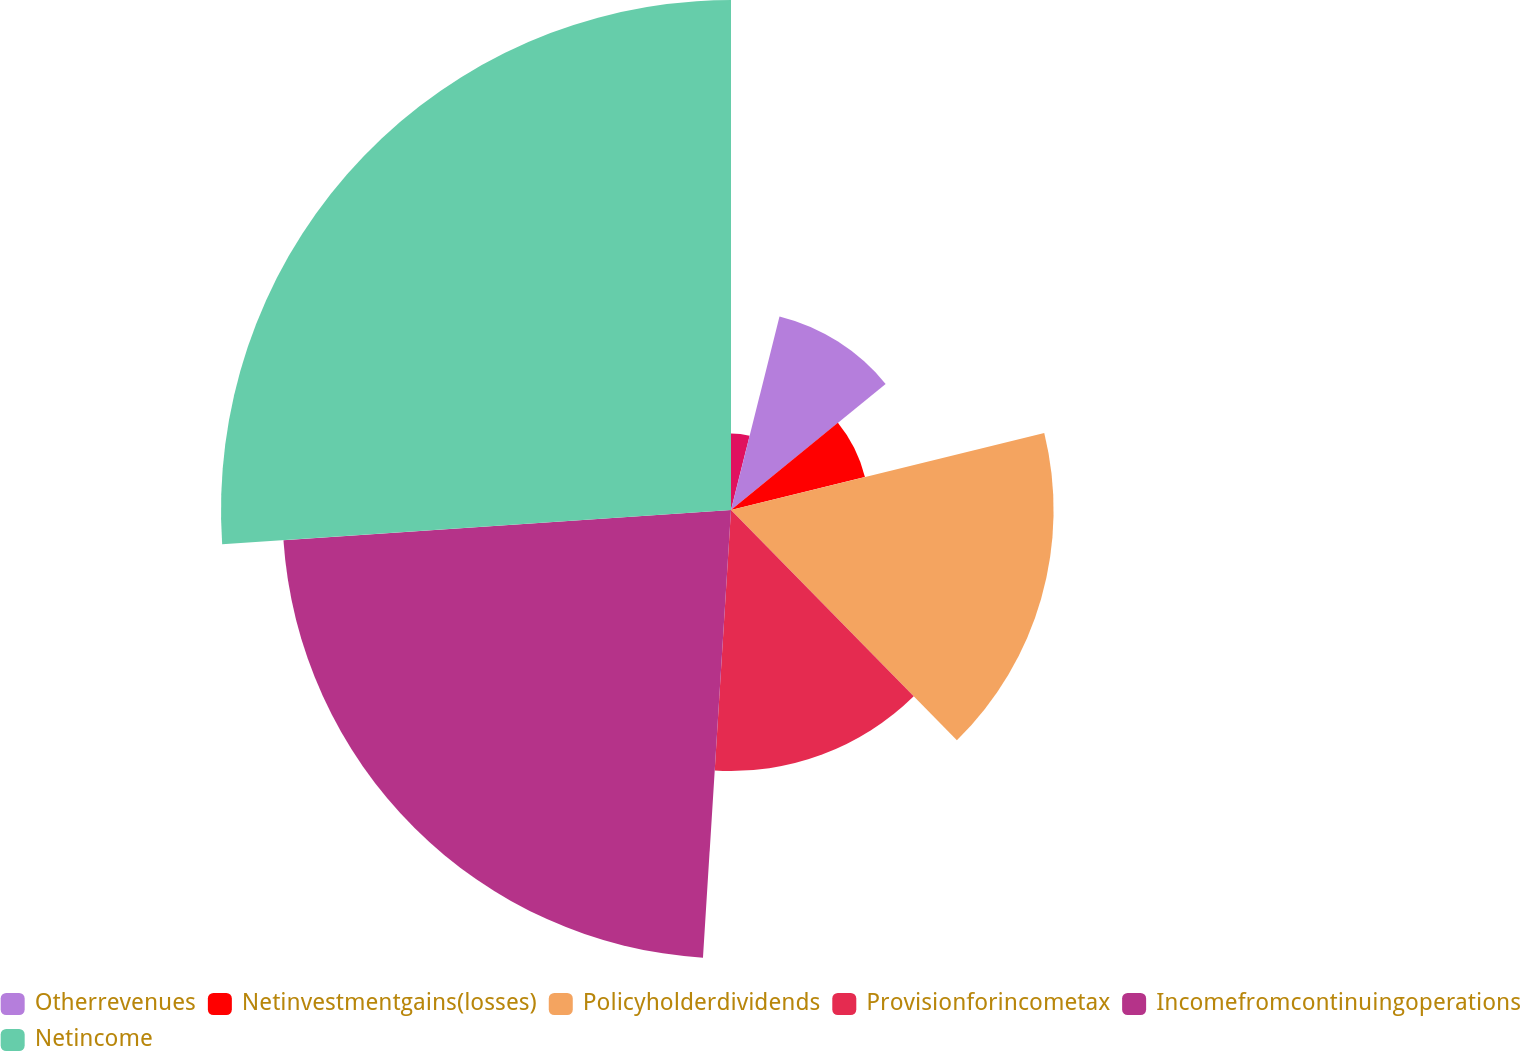Convert chart to OTSL. <chart><loc_0><loc_0><loc_500><loc_500><pie_chart><ecel><fcel>Otherrevenues<fcel>Netinvestmentgains(losses)<fcel>Policyholderdividends<fcel>Provisionforincometax<fcel>Incomefromcontinuingoperations<fcel>Netincome<nl><fcel>3.91%<fcel>10.2%<fcel>7.05%<fcel>16.49%<fcel>13.34%<fcel>22.93%<fcel>26.07%<nl></chart> 